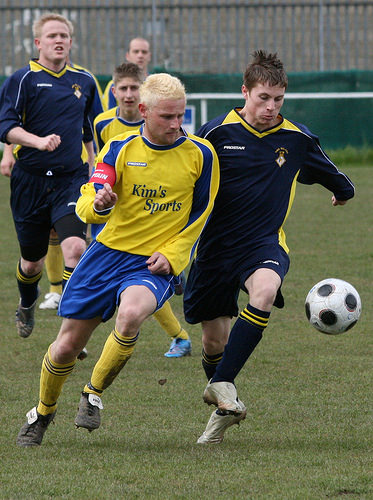<image>
Is the ball on the ground? No. The ball is not positioned on the ground. They may be near each other, but the ball is not supported by or resting on top of the ground. Is there a player to the left of the ball? Yes. From this viewpoint, the player is positioned to the left side relative to the ball. 